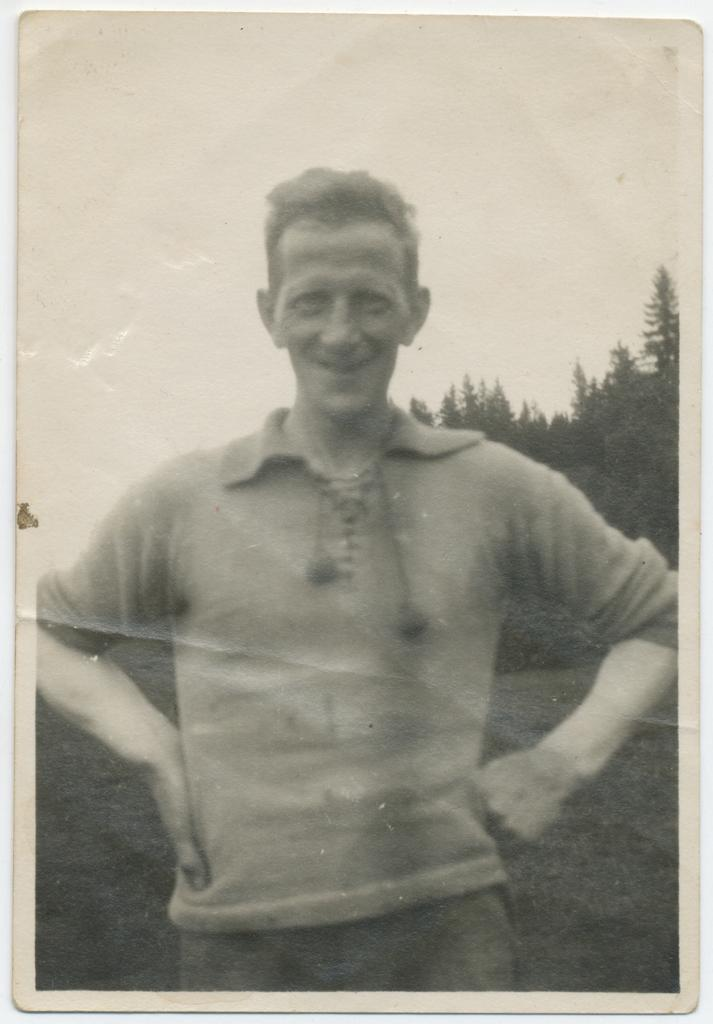What type of image is present in the picture? There is an old photograph in the image. Who is featured in the photograph? The photograph features a man. What is the man doing in the photograph? The man is standing with his hands on his hips. What is the man's facial expression in the photograph? The man is smiling. What can be seen behind the man in the photograph? There is a part of a tree visible behind the man. What is visible in the background of the photograph? The sky is visible in the background. What type of beef is hanging from the tree in the image? There is no beef present in the image; it features an old photograph of a man. Is the bulb in the image providing light for the man? There is no mention of a bulb in the image; it only features an old photograph of a man. 